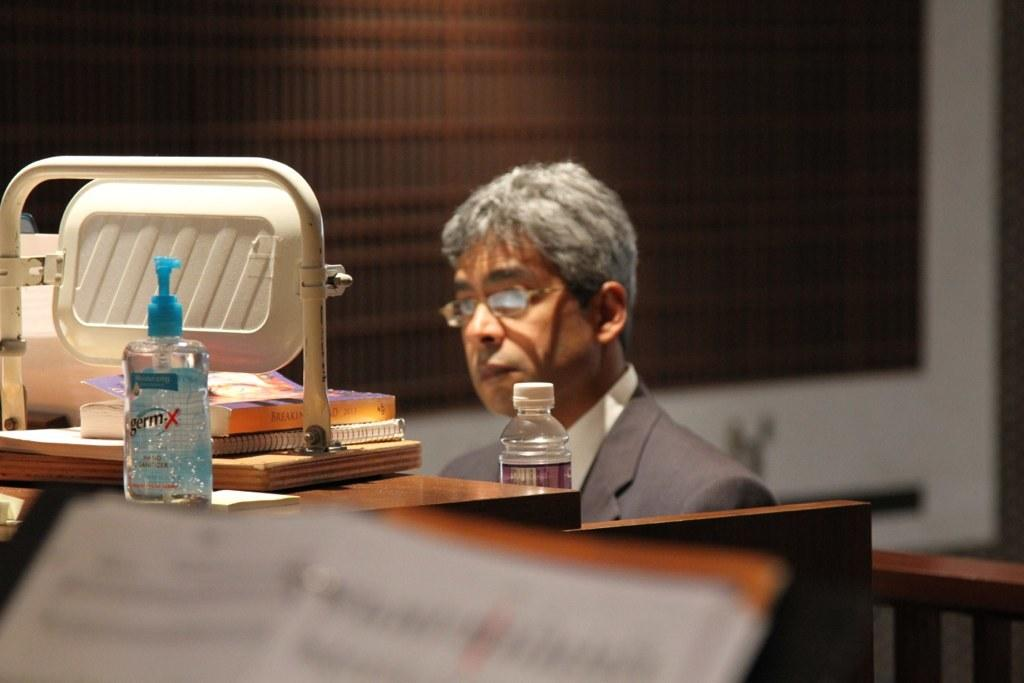<image>
Describe the image concisely. Man sitting behind a desk with a germ-X on top. 